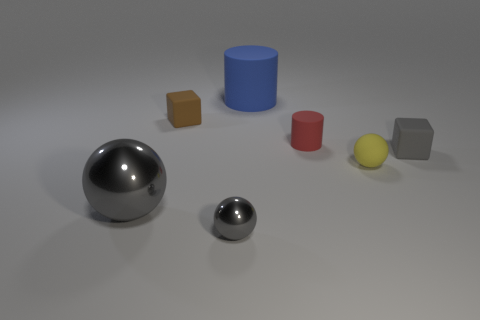Subtract all gray balls. How many balls are left? 1 Add 3 tiny matte cubes. How many objects exist? 10 Subtract all yellow cubes. How many gray balls are left? 2 Subtract 1 yellow balls. How many objects are left? 6 Subtract all blocks. How many objects are left? 5 Subtract all purple cubes. Subtract all red cylinders. How many cubes are left? 2 Subtract all big blue matte cylinders. Subtract all metal things. How many objects are left? 4 Add 6 tiny yellow rubber objects. How many tiny yellow rubber objects are left? 7 Add 1 small purple shiny objects. How many small purple shiny objects exist? 1 